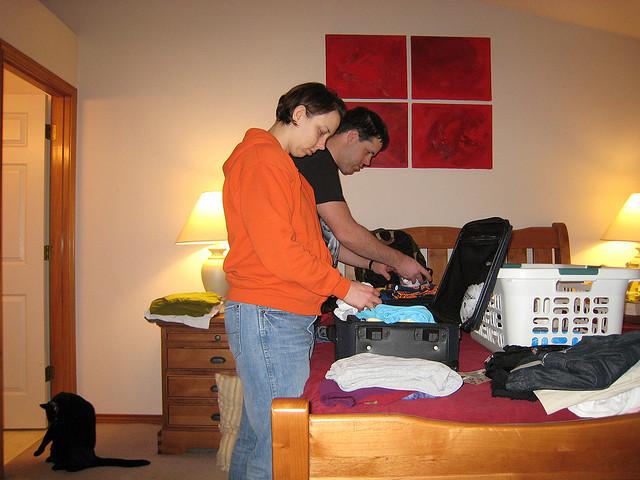What is the cat doing?
Give a very brief answer. Licking himself. What is the bed made of?
Answer briefly. Wood. How many men are there?
Quick response, please. 1. 